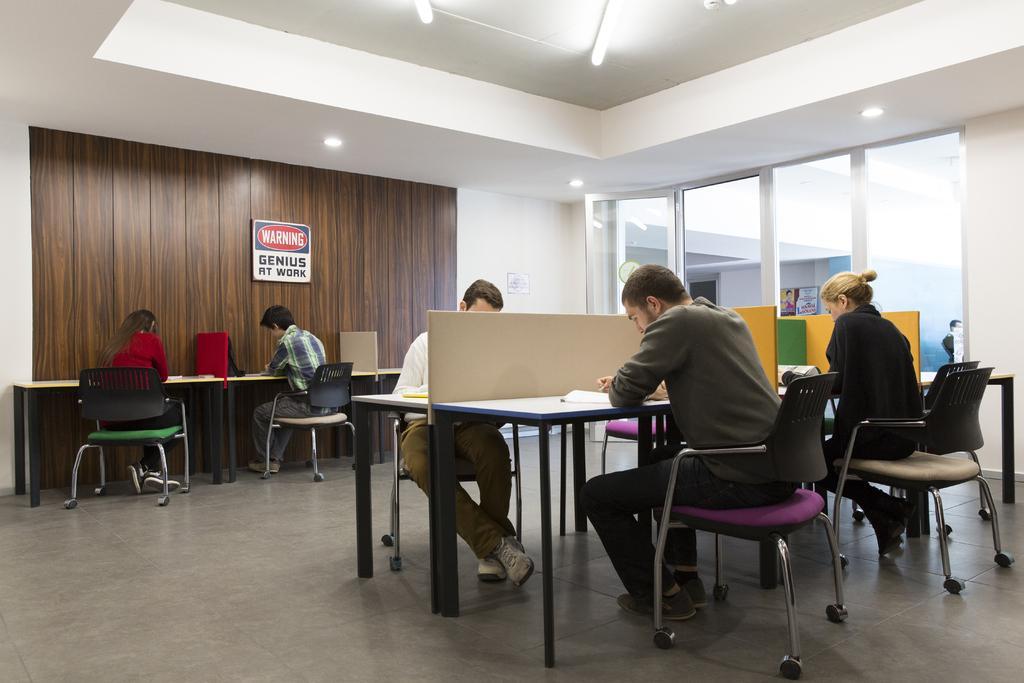Describe this image in one or two sentences. In this image this picture is taken in the office where a group of persons are sitting on a chair and doing work on their desk. In the background there is a board with the words warning genius at work and a window with a glass on it. 